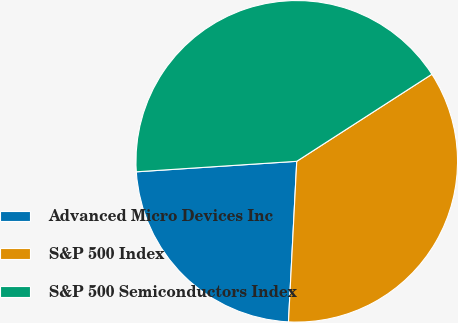Convert chart. <chart><loc_0><loc_0><loc_500><loc_500><pie_chart><fcel>Advanced Micro Devices Inc<fcel>S&P 500 Index<fcel>S&P 500 Semiconductors Index<nl><fcel>23.14%<fcel>34.93%<fcel>41.93%<nl></chart> 